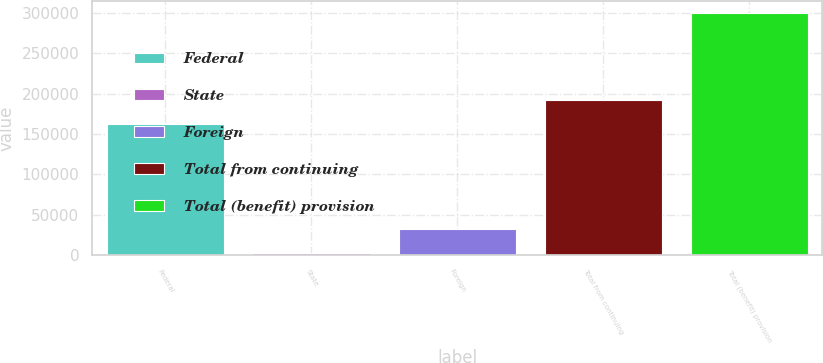Convert chart to OTSL. <chart><loc_0><loc_0><loc_500><loc_500><bar_chart><fcel>Federal<fcel>State<fcel>Foreign<fcel>Total from continuing<fcel>Total (benefit) provision<nl><fcel>162737<fcel>2421<fcel>32161.5<fcel>192478<fcel>299826<nl></chart> 